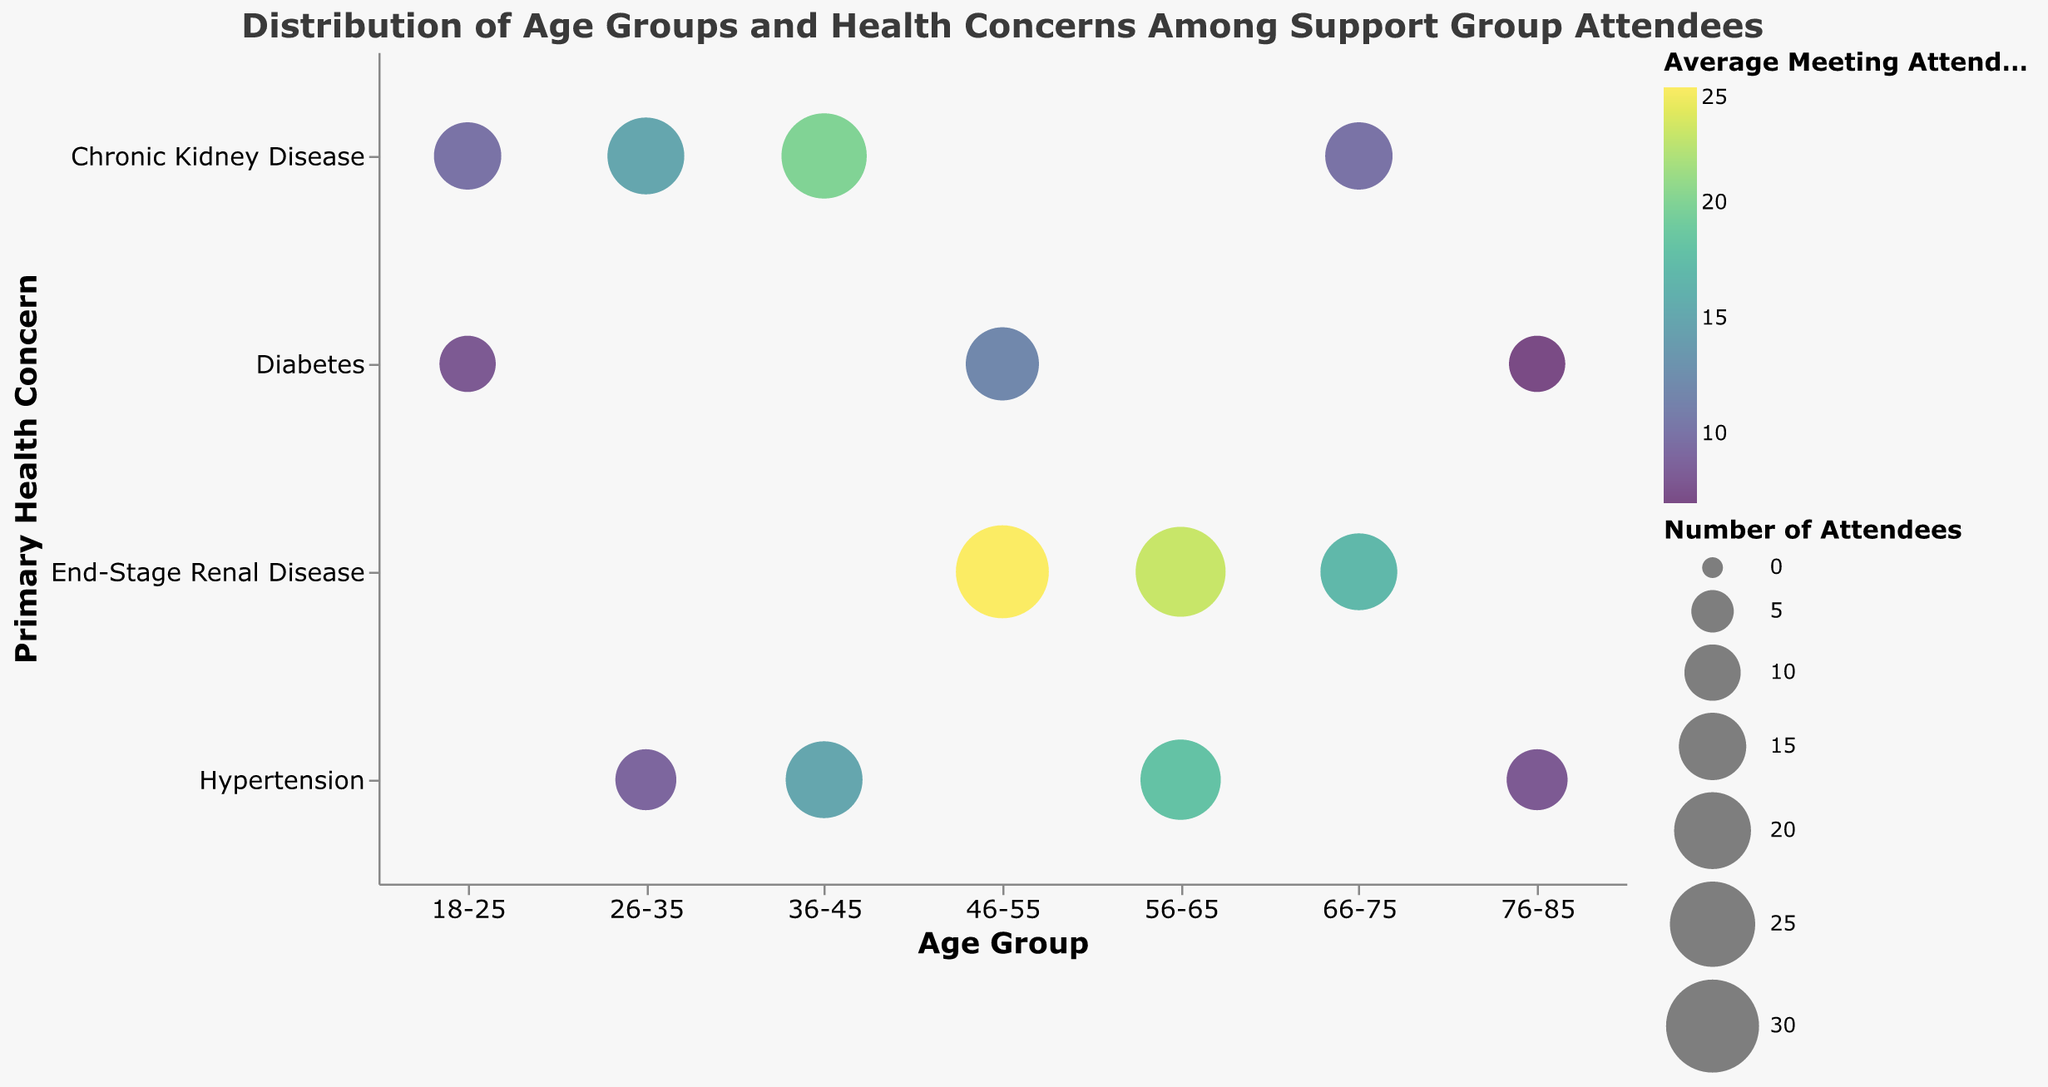What is the primary health concern among attendees aged 46-55 with the highest average meeting attendance? Look at the bubbles corresponding to the 46-55 age group and note the one with the largest bubble size and color indicating the highest average meeting attendance. The bubble representing 'End-Stage Renal Disease' has the highest average meeting attendance of 25.
Answer: End-Stage Renal Disease Which age group has the most attendees for Chronic Kidney Disease, and what is the size of this bubble? Find the bubbles associated with 'Chronic Kidney Disease' and compare their sizes (i.e., number of attendees). The largest bubble in this category is in the 36-45 age group with 25 attendees.
Answer: 36-45: 25 attendees How does the average meeting attendance for Diabetes among attendees aged 18-25 compare to that among attendees aged 76-85? Locate the bubbles for 'Diabetes' in the 18-25 and 76-85 age groups and compare the color intensity, which represents average meeting attendance. The average meeting attendance for Diabetes is 8 for 18-25 and 7 for 76-85.
Answer: 18-25: 8, 76-85: 7 What is the total number of attendees for End-Stage Renal Disease across all age groups? Add the number of attendees for all bubbles labeled 'End-Stage Renal Disease': 46-55 (30) + 56-65 (28) + 66-75 (20). The total is 30 + 28 + 20 = 78.
Answer: 78 Which age group has the highest average meeting attendance for Diabetes? Focus on the bubbles labeled 'Diabetes' and compare their colors indicating average meeting attendance. The 46-55 age group, with an average meeting attendance of 12, is the highest.
Answer: 46-55 What is the smallest number of attendees for any health concern in any age group, and which age group and health concern does it correspond to? Identify the smallest bubble across all segments. The smallest bubble represents 'Diabetes' in the 76-85 age group, with only 10 attendees.
Answer: Diabetes in 76-85: 10 attendees Which age group has more attendees with Hypertension, 36-45 or 56-65? Compare the sizes of the bubbles for Hypertension in the 36-45 (20 attendees) and 56-65 (22 attendees) age groups. The 56-65 age group has more attendees.
Answer: 56-65: 22 attendees Considering attendees of all age groups, which primary health concern has the highest total average meeting attendance when summed across all concerned age groups? Sum the average meeting attendance values for each primary health concern. 'End-Stage Renal Disease' has 25 (46-55) + 23 (56-65) + 17 (66-75) = 65, the highest total average meeting attendance.
Answer: End-Stage Renal Disease 